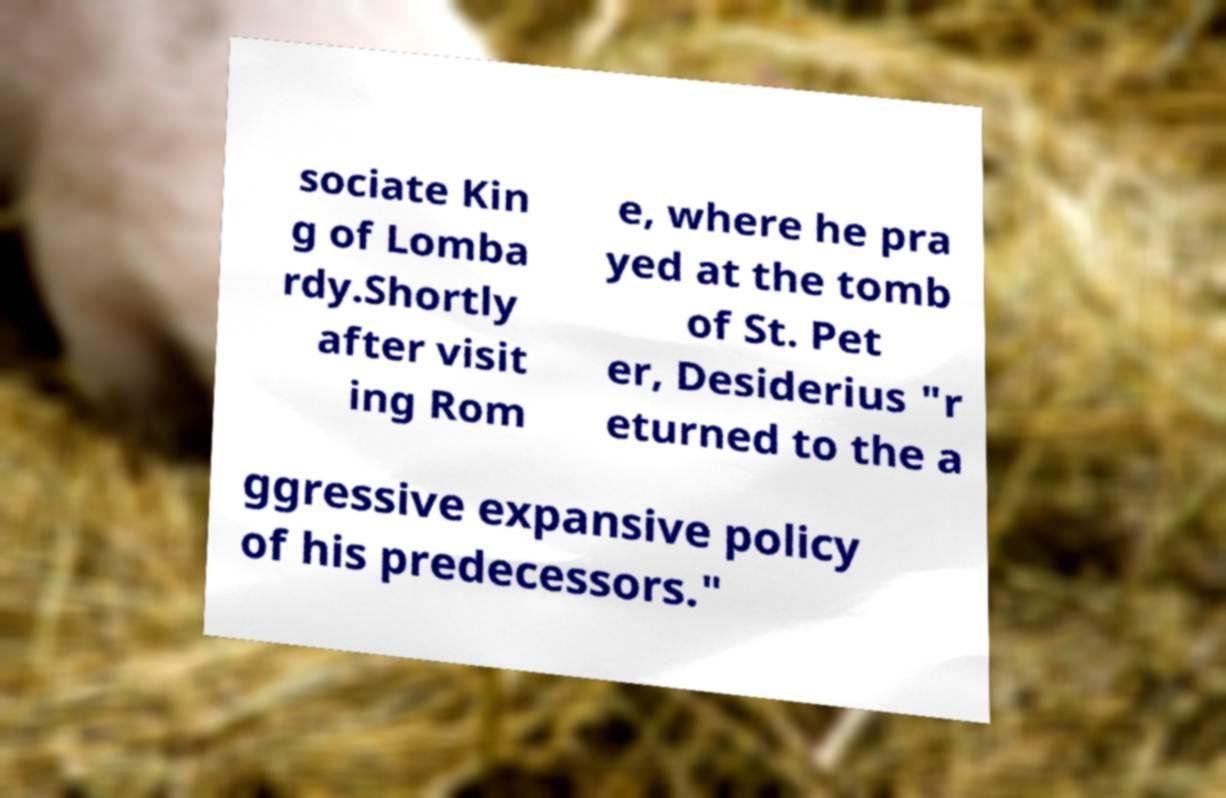I need the written content from this picture converted into text. Can you do that? sociate Kin g of Lomba rdy.Shortly after visit ing Rom e, where he pra yed at the tomb of St. Pet er, Desiderius "r eturned to the a ggressive expansive policy of his predecessors." 